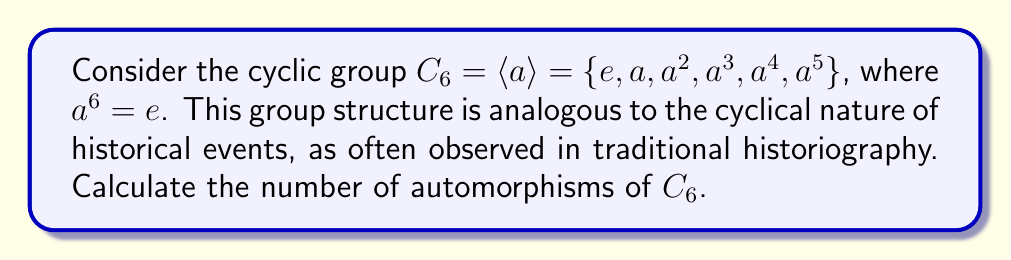Can you solve this math problem? To determine the number of automorphisms of $C_6$, we'll follow these steps:

1) An automorphism of a cyclic group is completely determined by where it sends the generator. In this case, we need to count how many ways we can map the generator $a$ to other elements that can generate the entire group.

2) The elements that can generate $C_6$ are those that have order 6. To find these, we need to determine which elements $a^k$ satisfy:
   $$(a^k)^6 = e \text{ and } (a^k)^m \neq e \text{ for } 1 \leq m < 6$$

3) We can see that:
   - $k = 1: a^6 = e$, generates the group
   - $k = 2: (a^2)^3 = e$, doesn't generate the group
   - $k = 3: (a^3)^2 = e$, doesn't generate the group
   - $k = 4: (a^4)^3 = (a^2)^6 = e$, doesn't generate the group
   - $k = 5: (a^5)^6 = a^{30} = (a^6)^5 = e^5 = e$, generates the group

4) Therefore, there are only two elements that generate the group: $a$ and $a^5$.

5) This means there are only two possible automorphisms:
   - $\phi_1: a \mapsto a$
   - $\phi_2: a \mapsto a^5$

6) We can verify that $\phi_2$ is indeed an automorphism:
   $\phi_2(a^2) = (\phi_2(a))^2 = (a^5)^2 = a^4$
   $\phi_2(a^3) = (\phi_2(a))^3 = (a^5)^3 = a^3$
   $\phi_2(a^4) = (\phi_2(a))^4 = (a^5)^4 = a^2$
   $\phi_2(a^5) = (\phi_2(a))^5 = (a^5)^5 = a$

Thus, there are 2 automorphisms of $C_6$.
Answer: The number of automorphisms of $C_6$ is 2. 